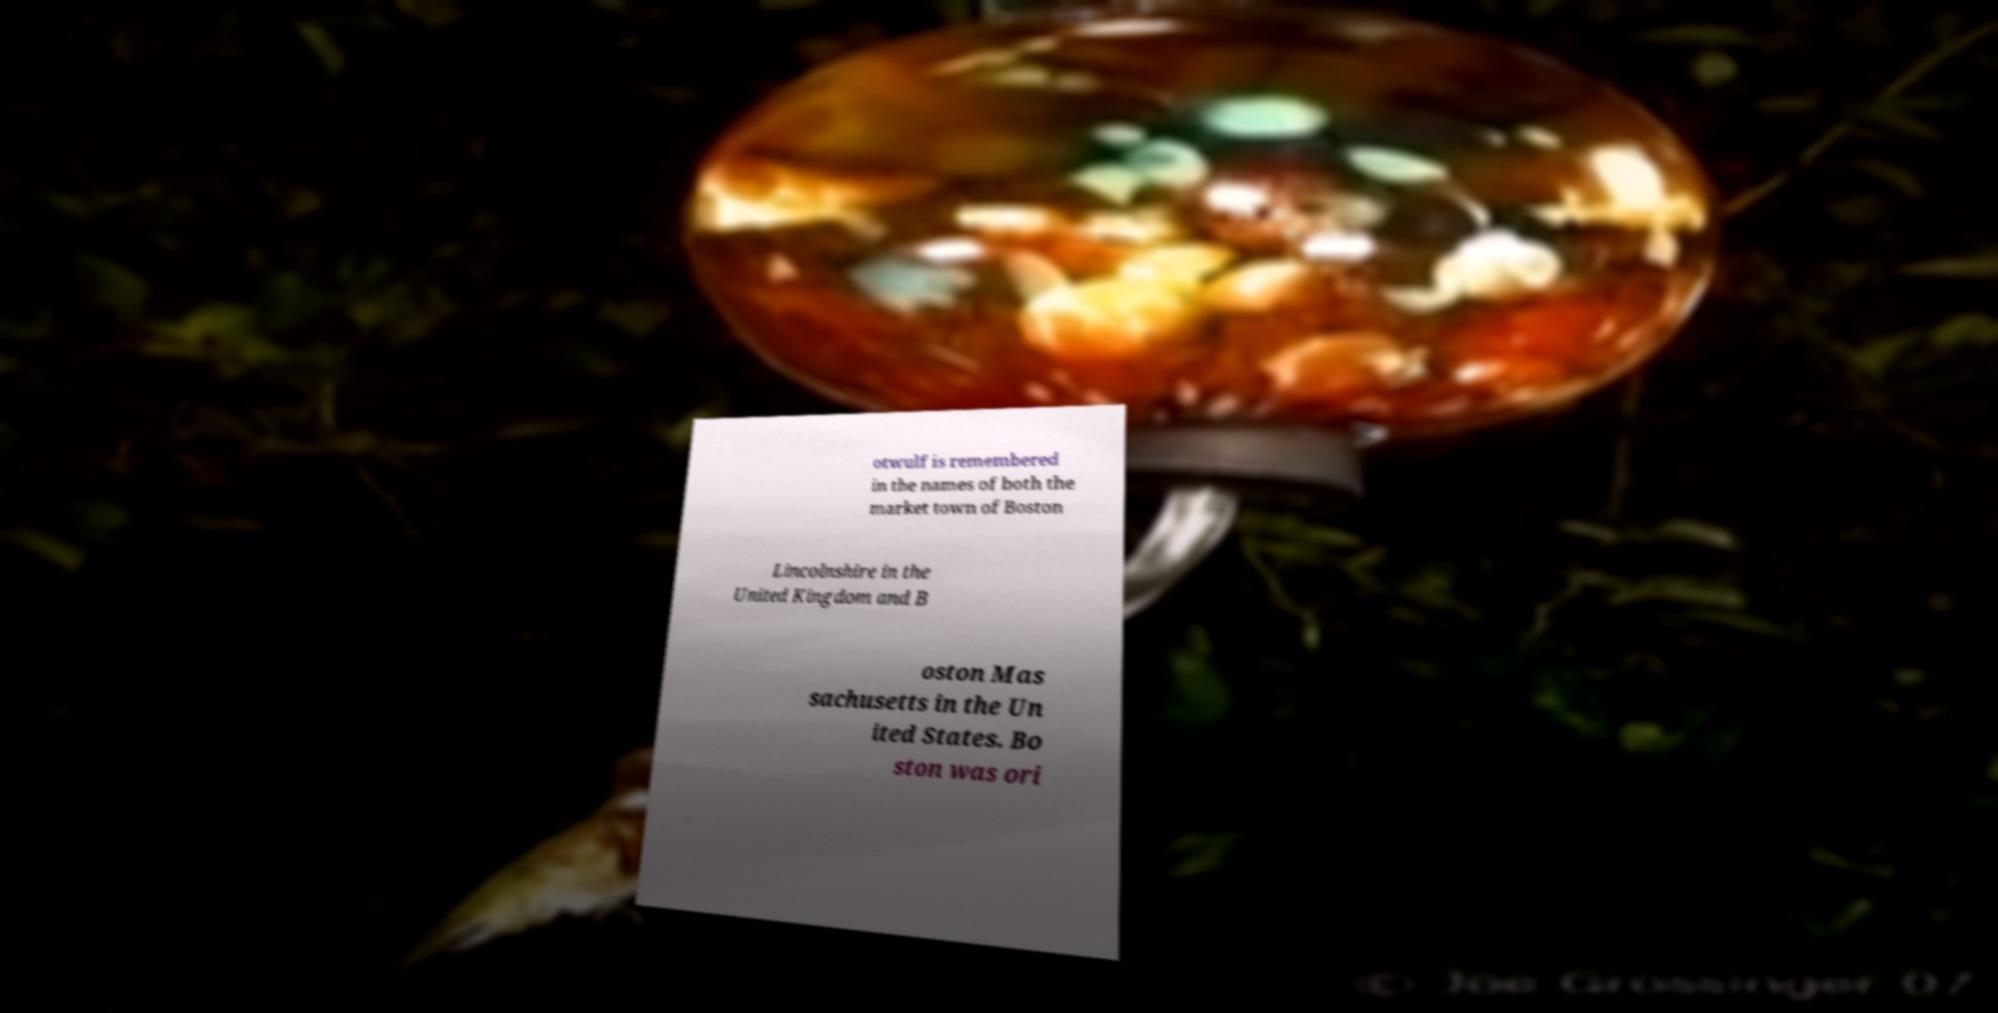Please read and relay the text visible in this image. What does it say? otwulf is remembered in the names of both the market town of Boston Lincolnshire in the United Kingdom and B oston Mas sachusetts in the Un ited States. Bo ston was ori 